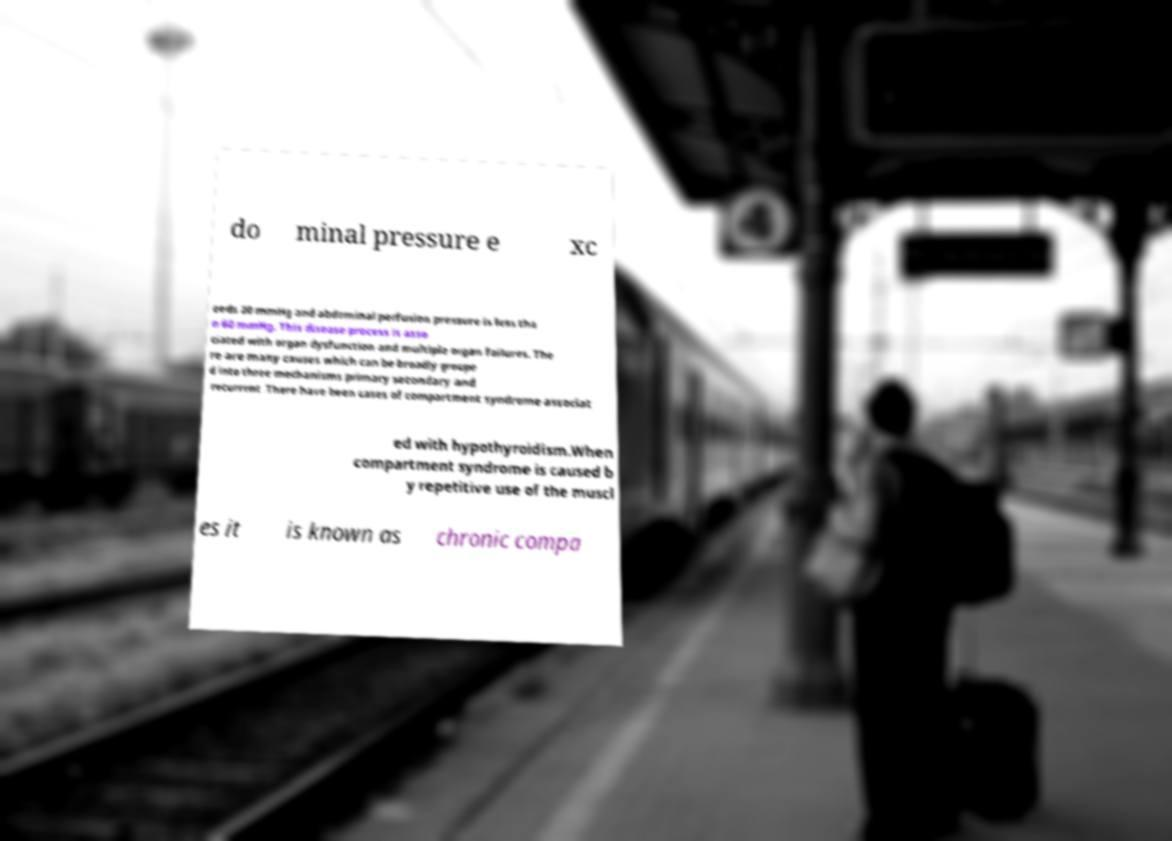Can you read and provide the text displayed in the image?This photo seems to have some interesting text. Can you extract and type it out for me? do minal pressure e xc eeds 20 mmHg and abdominal perfusion pressure is less tha n 60 mmHg. This disease process is asso ciated with organ dysfunction and multiple organ failures. The re are many causes which can be broadly groupe d into three mechanisms primary secondary and recurrent .There have been cases of compartment syndrome associat ed with hypothyroidism.When compartment syndrome is caused b y repetitive use of the muscl es it is known as chronic compa 